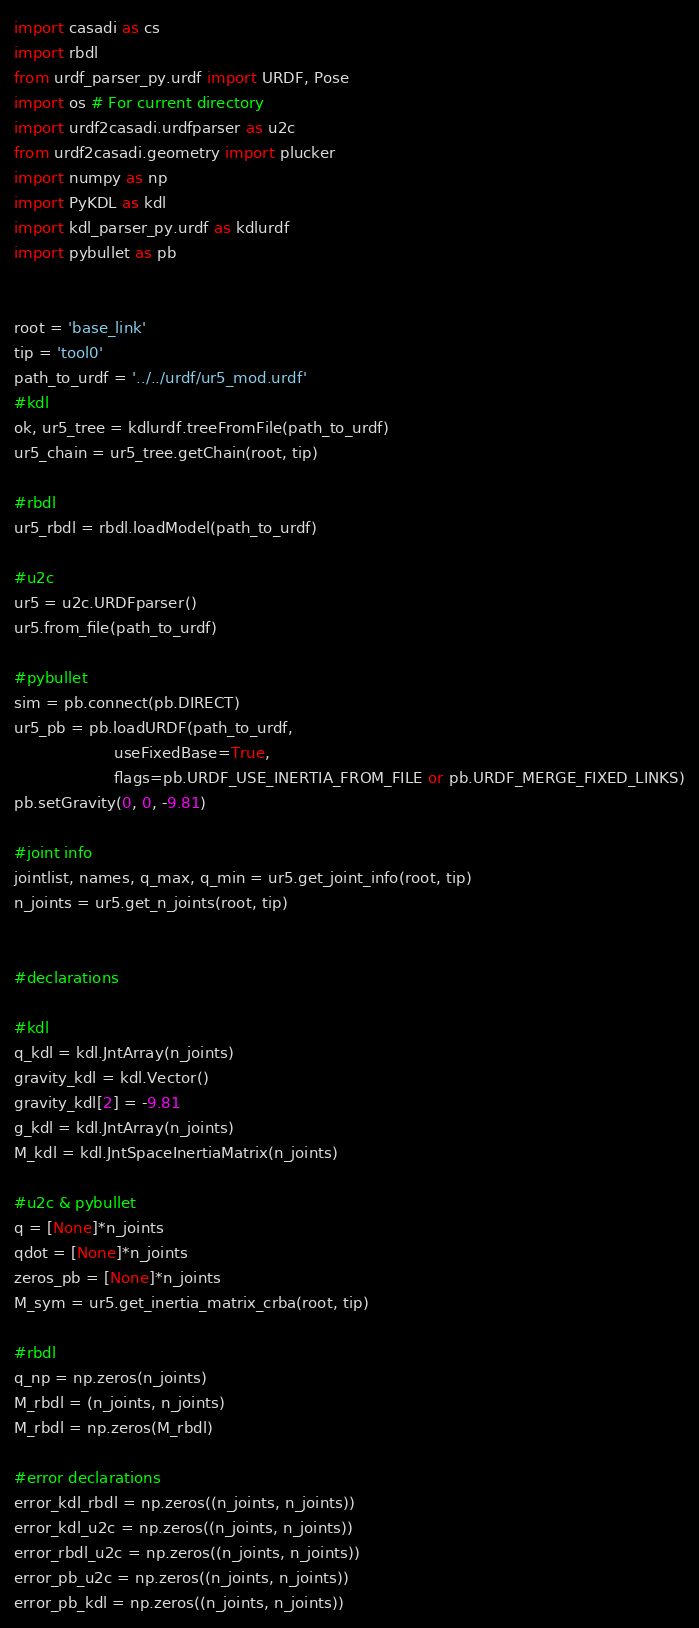<code> <loc_0><loc_0><loc_500><loc_500><_Python_>import casadi as cs
import rbdl
from urdf_parser_py.urdf import URDF, Pose
import os # For current directory
import urdf2casadi.urdfparser as u2c
from urdf2casadi.geometry import plucker
import numpy as np
import PyKDL as kdl
import kdl_parser_py.urdf as kdlurdf
import pybullet as pb


root = 'base_link'
tip = 'tool0'
path_to_urdf = '../../urdf/ur5_mod.urdf'
#kdl
ok, ur5_tree = kdlurdf.treeFromFile(path_to_urdf)
ur5_chain = ur5_tree.getChain(root, tip)

#rbdl
ur5_rbdl = rbdl.loadModel(path_to_urdf)

#u2c
ur5 = u2c.URDFparser()
ur5.from_file(path_to_urdf)

#pybullet
sim = pb.connect(pb.DIRECT)
ur5_pb = pb.loadURDF(path_to_urdf,
                     useFixedBase=True,
                     flags=pb.URDF_USE_INERTIA_FROM_FILE or pb.URDF_MERGE_FIXED_LINKS)
pb.setGravity(0, 0, -9.81)

#joint info
jointlist, names, q_max, q_min = ur5.get_joint_info(root, tip)
n_joints = ur5.get_n_joints(root, tip)


#declarations

#kdl
q_kdl = kdl.JntArray(n_joints)
gravity_kdl = kdl.Vector()
gravity_kdl[2] = -9.81
g_kdl = kdl.JntArray(n_joints)
M_kdl = kdl.JntSpaceInertiaMatrix(n_joints)

#u2c & pybullet
q = [None]*n_joints
qdot = [None]*n_joints
zeros_pb = [None]*n_joints
M_sym = ur5.get_inertia_matrix_crba(root, tip)

#rbdl
q_np = np.zeros(n_joints)
M_rbdl = (n_joints, n_joints)
M_rbdl = np.zeros(M_rbdl)

#error declarations
error_kdl_rbdl = np.zeros((n_joints, n_joints))
error_kdl_u2c = np.zeros((n_joints, n_joints))
error_rbdl_u2c = np.zeros((n_joints, n_joints))
error_pb_u2c = np.zeros((n_joints, n_joints))
error_pb_kdl = np.zeros((n_joints, n_joints))</code> 